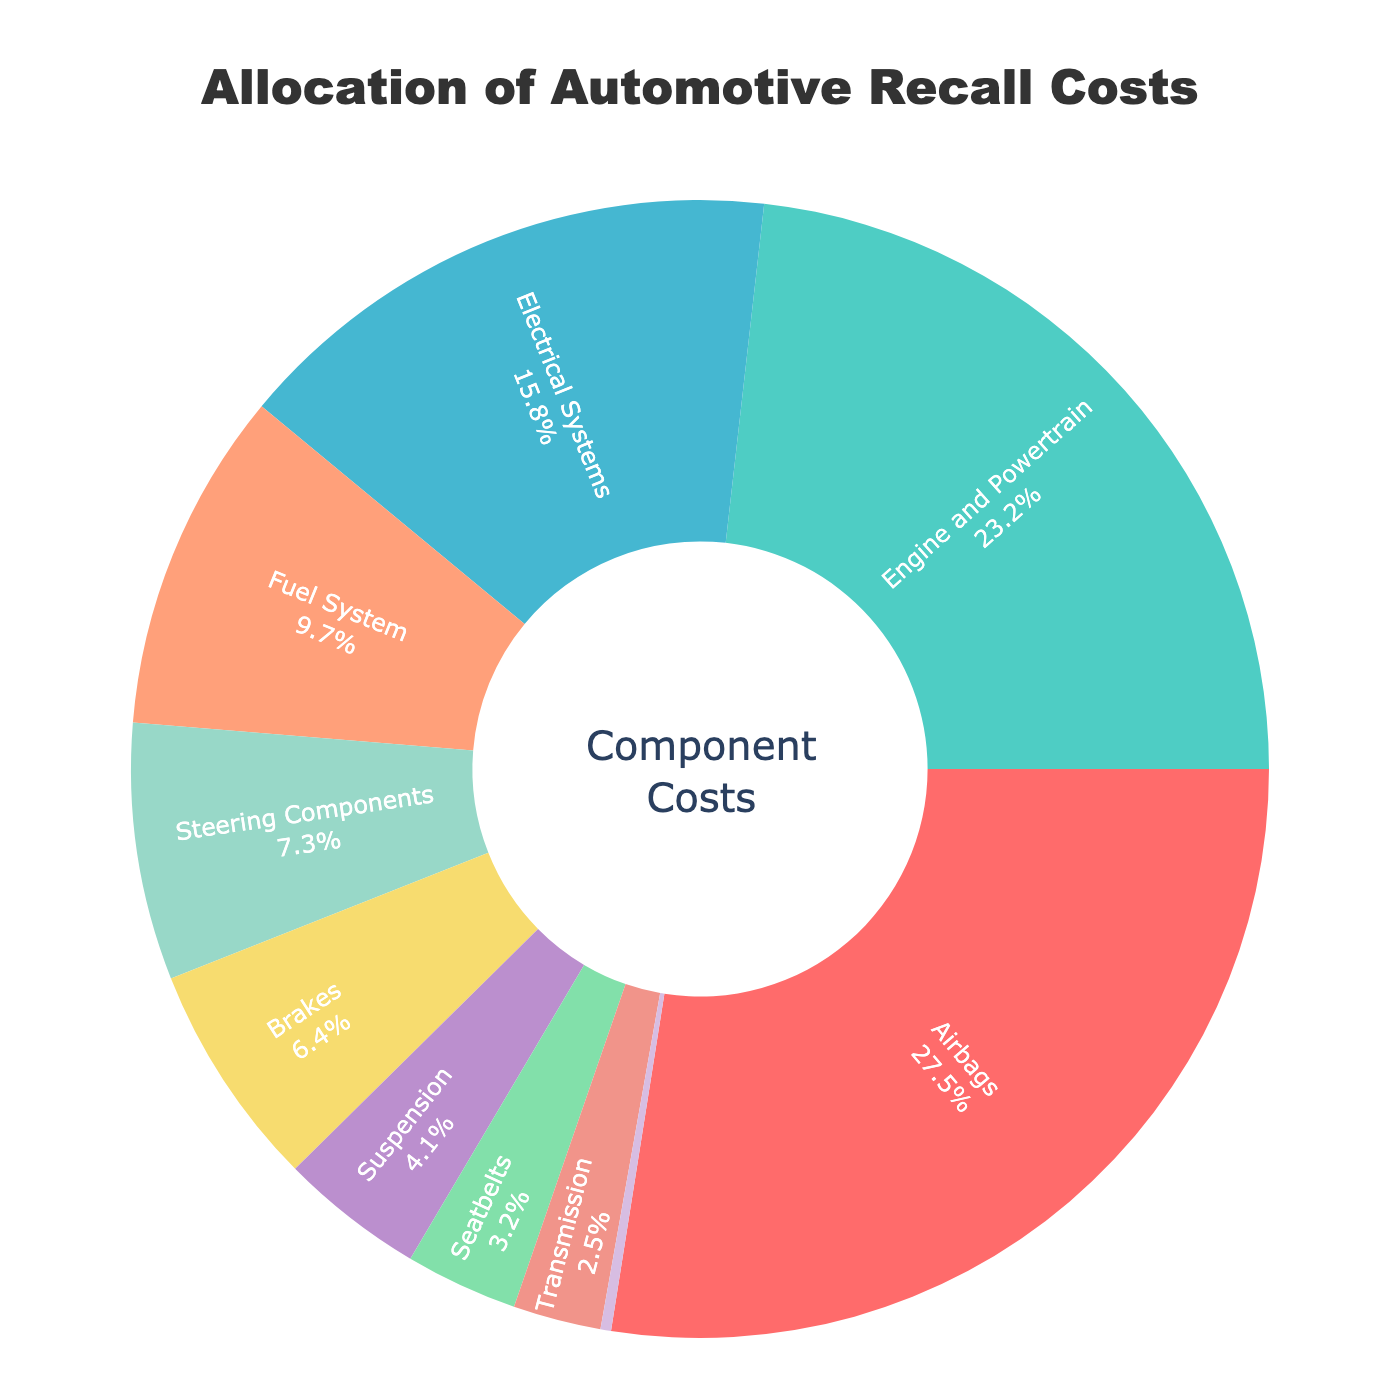what is the percentage difference between the recalls due to Airbags and Brakes? From the chart, Airbags account for 27.5% of the recall costs, while Brakes account for 6.4%. The percentage difference is calculated as 27.5 - 6.4 = 21.1%
Answer: 21.1% Which component has the smallest allocation of recall costs? From the chart, the HVAC System has the smallest allocation of recall costs, represented by the smallest segment.
Answer: HVAC System What is the combined recall percentage for Electrical Systems and Engine and Powertrain? Electrical Systems have 15.8% and Engine and Powertrain have 23.2%. Summing these gives 15.8 + 23.2 = 39.0%.
Answer: 39.0% Are there more recall costs allocated to Steering Components or Suspension? From the chart, Steering Components account for 7.3% of recall costs, while Suspension accounts for 4.1%. Since 7.3% > 4.1%, more costs are allocated to Steering Components.
Answer: Steering Components Which two components together represent exactly 12.9% of the recall costs? From the chart, Brakes represent 6.4% and Seatbelts represent 3.2%. Together they make 6.4 + 3.2 = 9.6%. This does not sum to 12.9%, so we look again. Suspension and Transmission have 4.1% and 2.5%, which sum to 6.6%. Analyzing other combinations, no exact match for 12.9% allocation exists.
Answer: No exact match If you combine the costs associated with Suspension, Brakes, and Transmission, do they exceed those due to Electrical Systems alone? Suspension is 4.1%, Brakes are 6.4%, and Transmission is 2.5%. Combined, they add up to 4.1 + 6.4 + 2.5 = 13. This is less than the 15.8% for Electrical Systems alone.
Answer: No Which of the colored segments appears the largest on the chart? The largest segment is colored red and represents the Airbags, which account for 27.5% of the total recall costs.
Answer: Airbags How many components account for less than 5% of the recall costs each? From the chart, these components are Suspension (4.1%), Seatbelts (3.2%), Transmission (2.5%), and HVAC System (0.3%). Counting them, we find there are 4 such components.
Answer: 4 